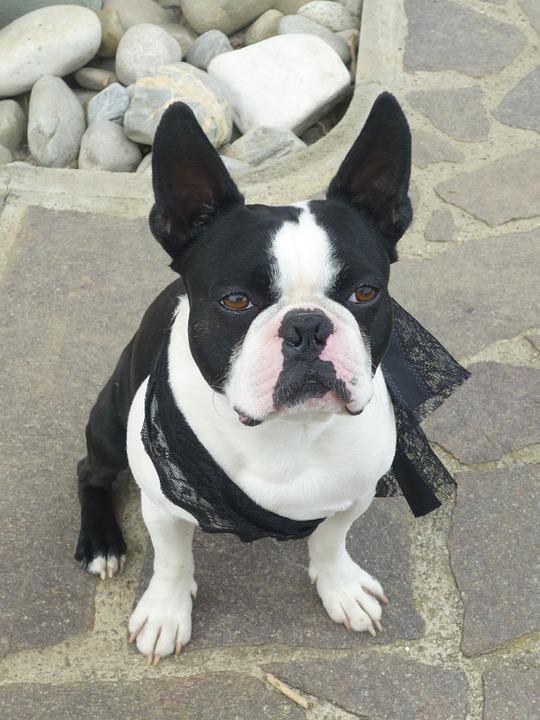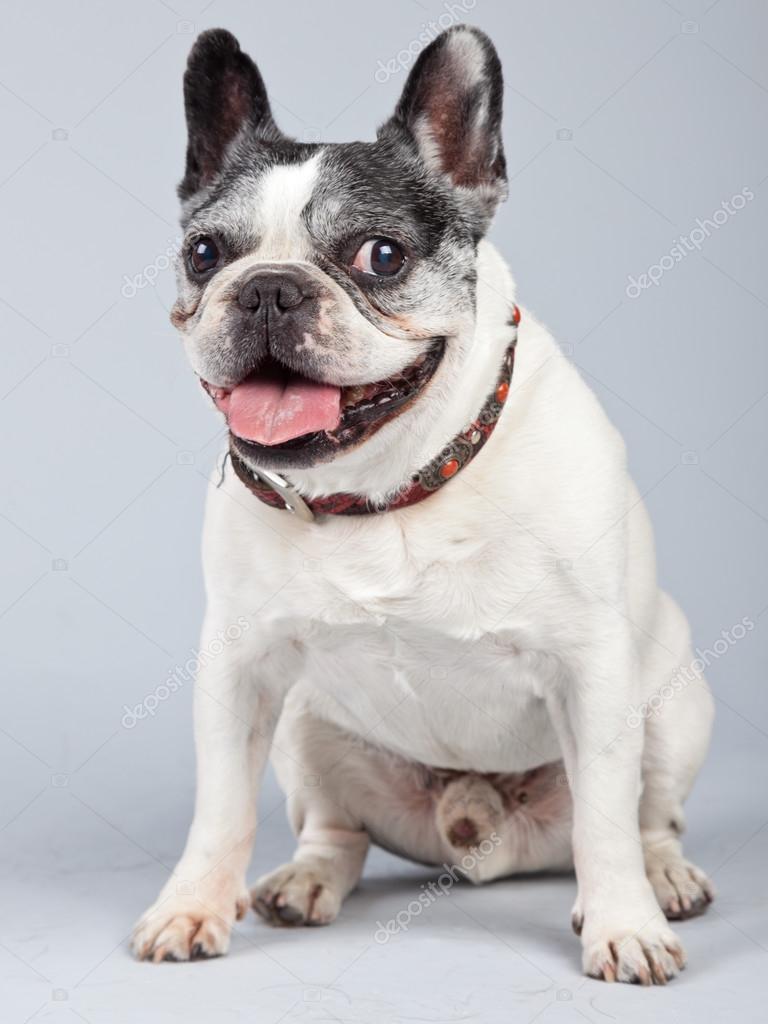The first image is the image on the left, the second image is the image on the right. Considering the images on both sides, is "Each image shows one sitting dog with black-and-white coloring, at least on its face." valid? Answer yes or no. Yes. 